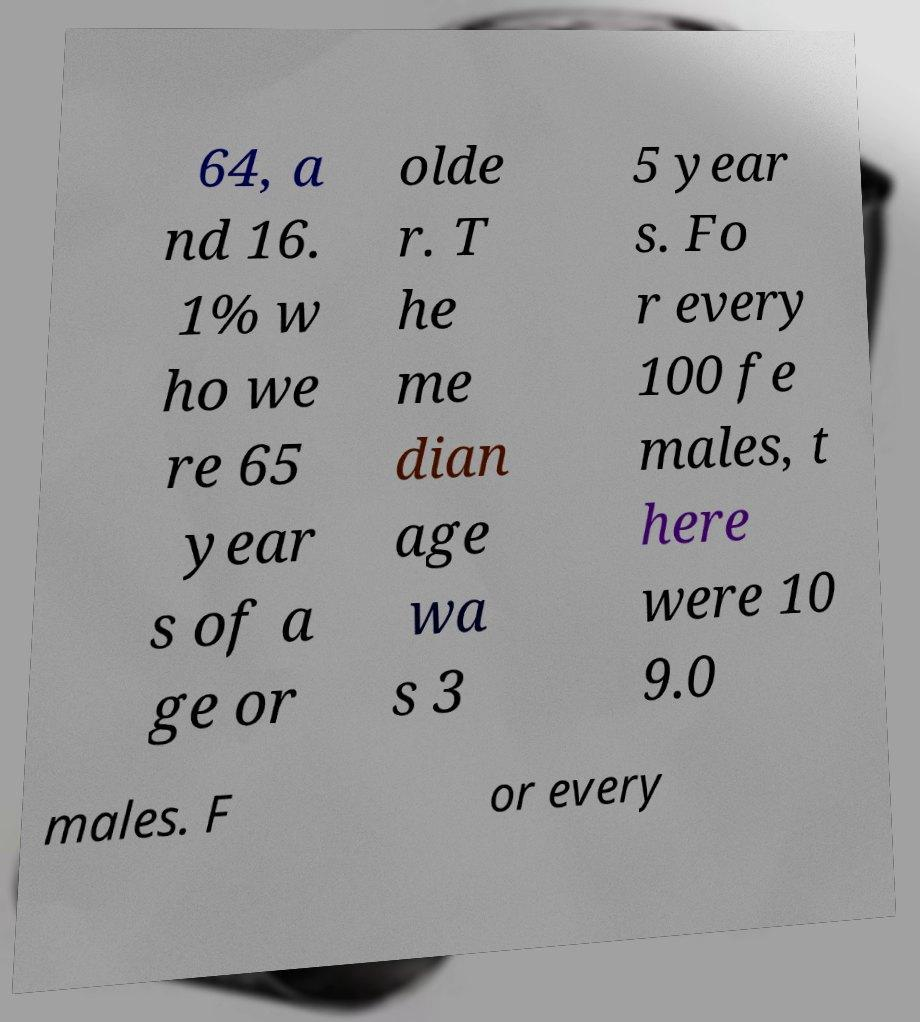I need the written content from this picture converted into text. Can you do that? 64, a nd 16. 1% w ho we re 65 year s of a ge or olde r. T he me dian age wa s 3 5 year s. Fo r every 100 fe males, t here were 10 9.0 males. F or every 